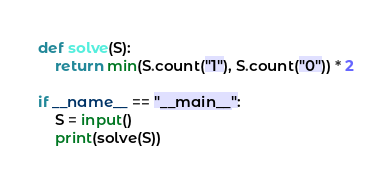<code> <loc_0><loc_0><loc_500><loc_500><_Python_>def solve(S):
    return min(S.count("1"), S.count("0")) * 2

if __name__ == "__main__":
    S = input()
    print(solve(S))
</code> 